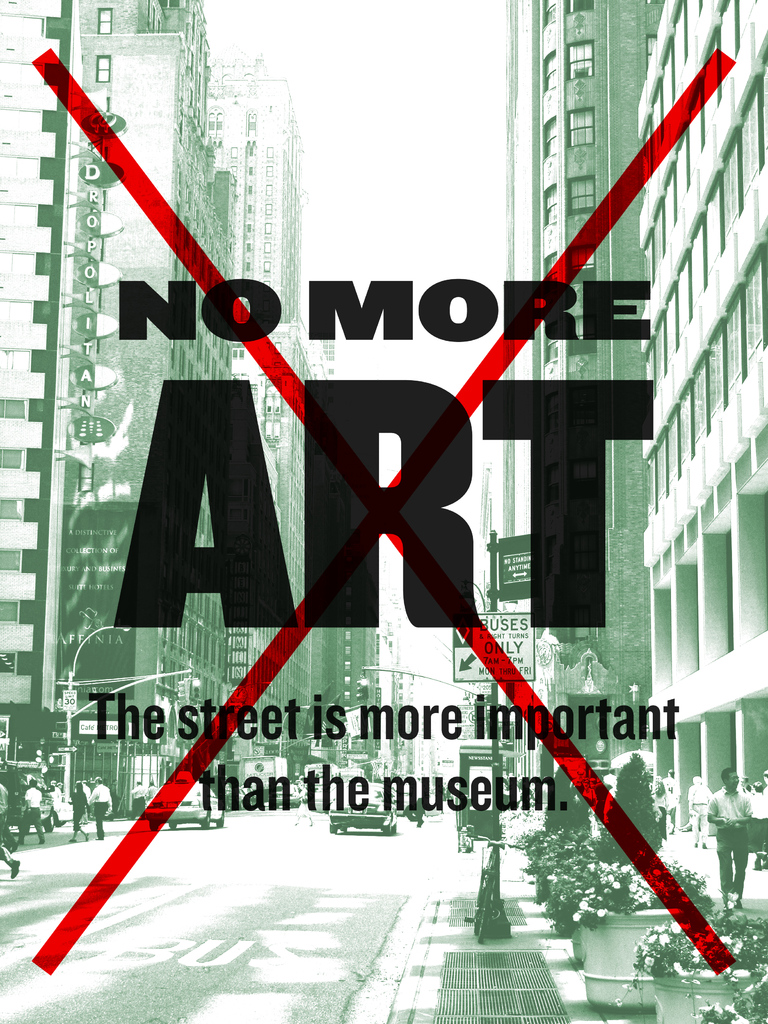Could the message in this image suggest a new direction for artists? Absolutely. The image prompts artists to explore and embrace non-traditional spaces and mediums for their art. By advocating 'The street is more important than the museum,' it encourages artists to think outside conventional frameworks and use public spaces as their canvas. This could mean more public installations, interactive art that engages community participation, or art that addresses social issues directly in the environments where they are most prominent. It’s a call for artistic innovation that intervenes in everyday life. 